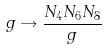<formula> <loc_0><loc_0><loc_500><loc_500>g \rightarrow \frac { N _ { 4 } N _ { 6 } N _ { 8 } } { g } \,</formula> 